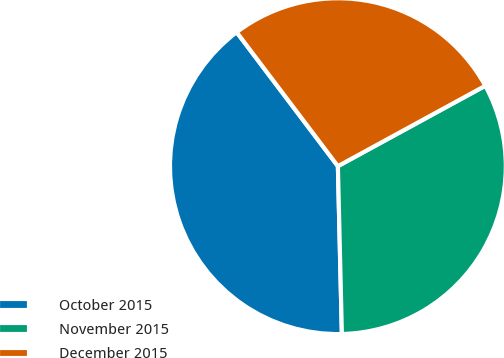<chart> <loc_0><loc_0><loc_500><loc_500><pie_chart><fcel>October 2015<fcel>November 2015<fcel>December 2015<nl><fcel>40.08%<fcel>32.57%<fcel>27.35%<nl></chart> 